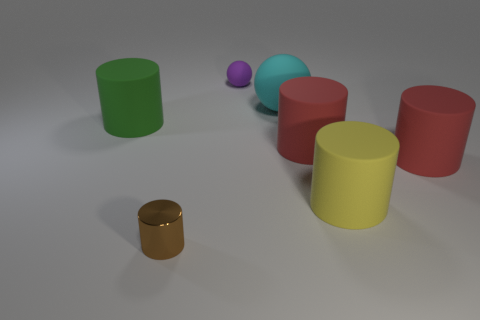Subtract all green cylinders. How many cylinders are left? 4 Subtract all green matte cylinders. How many cylinders are left? 4 Subtract all purple cylinders. Subtract all cyan cubes. How many cylinders are left? 5 Add 3 large cyan metal objects. How many objects exist? 10 Subtract all cylinders. How many objects are left? 2 Subtract all big yellow cylinders. Subtract all purple rubber spheres. How many objects are left? 5 Add 1 purple rubber objects. How many purple rubber objects are left? 2 Add 6 small red rubber spheres. How many small red rubber spheres exist? 6 Subtract 0 green blocks. How many objects are left? 7 